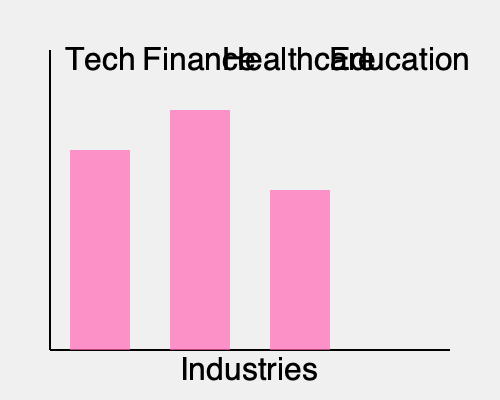The 3D bar graph shows the gender pay gap across different industries. Given that the average pay gap across all industries is 18%, and the sum of the pay gaps for Tech, Finance, and Healthcare is 60%, what should be the height of the Education industry bar to complete the graph? To solve this problem, let's follow these steps:

1. Identify the known pay gaps:
   - Tech: 20%
   - Finance: 24%
   - Healthcare: 16%

2. Calculate the sum of known pay gaps:
   $20\% + 24\% + 16\% = 60\%$

3. Let $x$ be the unknown pay gap for Education.

4. Set up an equation based on the average pay gap:
   The sum of all pay gaps divided by the number of industries should equal the average.
   $\frac{60\% + x}{4} = 18\%$

5. Solve the equation:
   $60\% + x = 18\% \times 4 = 72\%$
   $x = 72\% - 60\% = 12\%$

6. Convert the percentage to graph units:
   The graph uses a scale where 10% = 100 units
   So, 12% = 120 units

Therefore, the height of the Education industry bar should be 120 units to complete the graph and maintain the average pay gap of 18% across all industries.
Answer: 120 units 